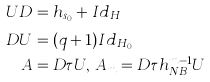<formula> <loc_0><loc_0><loc_500><loc_500>U D & = h _ { s _ { 0 } } + I d _ { H _ { \phi } } \\ D U & = ( q + 1 ) I d _ { H _ { 0 } } \\ A & = D \tau U , \, A _ { m } = D \tau h _ { N B } ^ { m - 1 } U</formula> 